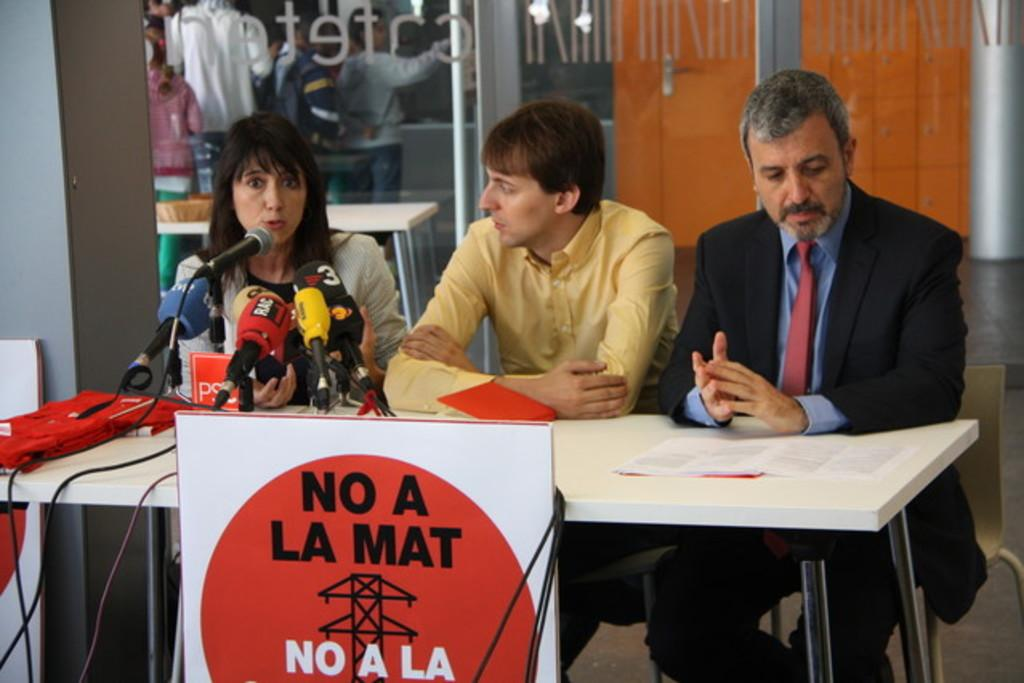Who is the main subject in the image? There is a woman in the image. What is the woman doing in the image? The woman is speaking at a press conference. Are there any other people in the image? Yes, there are two men in the image. What are the men doing in the image? The men are sitting beside the woman and listening to her. What type of lumber is being used to build the room in the image? There is no room or lumber present in the image; it features a woman speaking at a press conference with two men listening to her. 